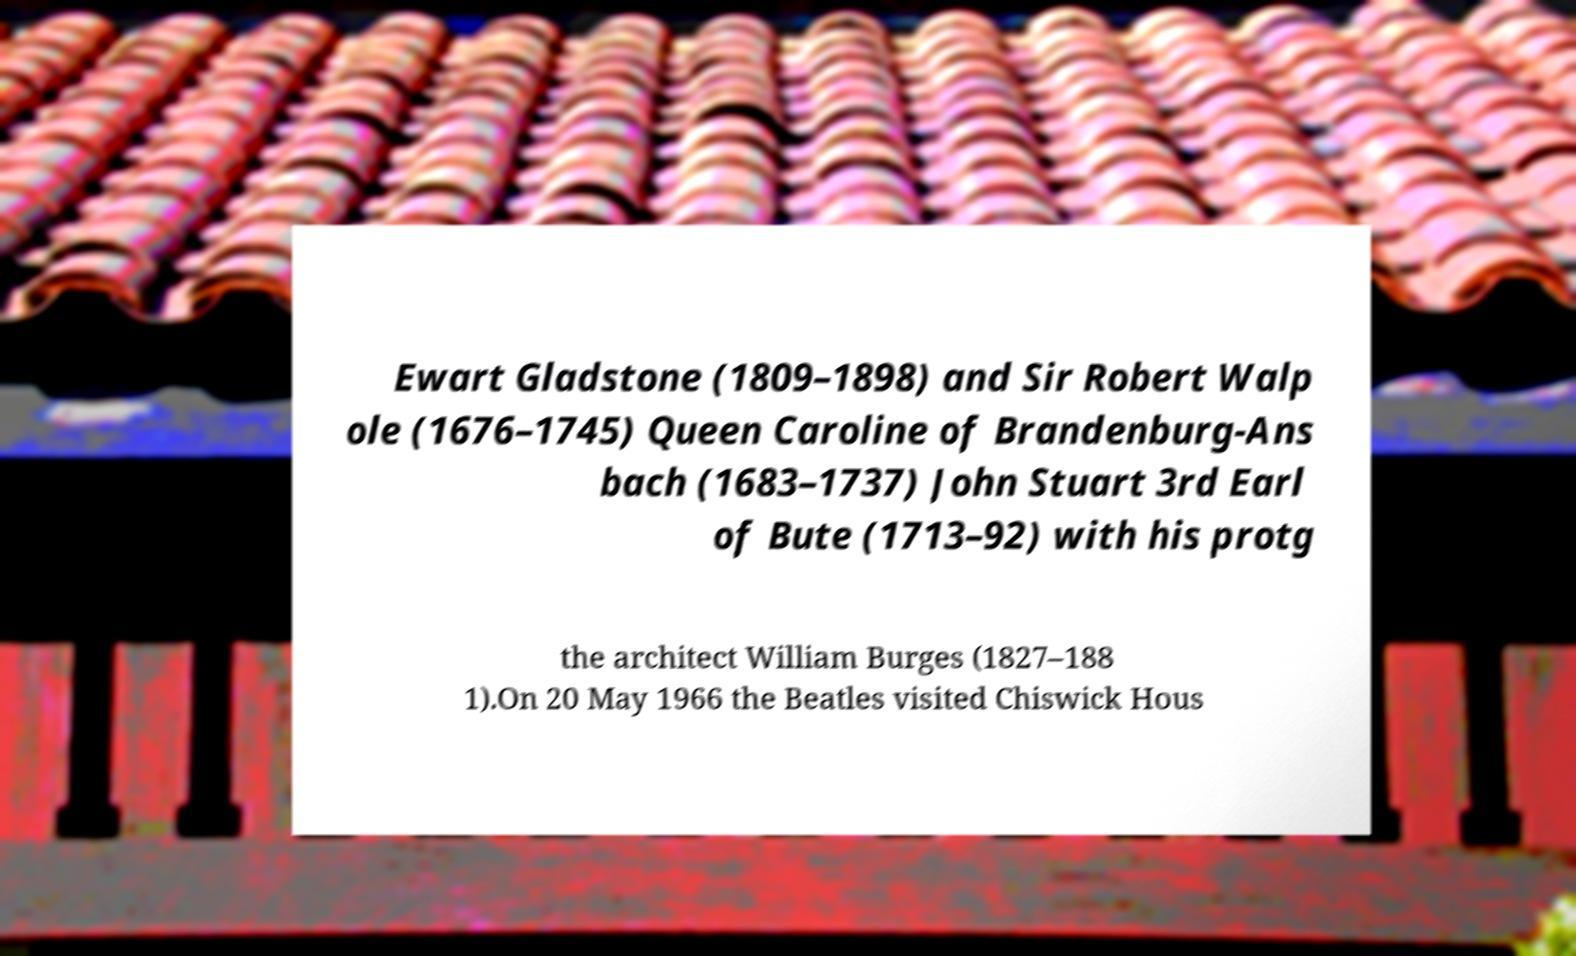Please identify and transcribe the text found in this image. Ewart Gladstone (1809–1898) and Sir Robert Walp ole (1676–1745) Queen Caroline of Brandenburg-Ans bach (1683–1737) John Stuart 3rd Earl of Bute (1713–92) with his protg the architect William Burges (1827–188 1).On 20 May 1966 the Beatles visited Chiswick Hous 